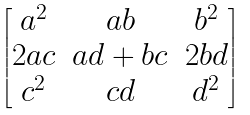<formula> <loc_0><loc_0><loc_500><loc_500>\begin{bmatrix} a ^ { 2 } & a b & b ^ { 2 } \\ 2 a c & a d + b c & 2 b d \\ c ^ { 2 } & c d & d ^ { 2 } \\ \end{bmatrix}</formula> 